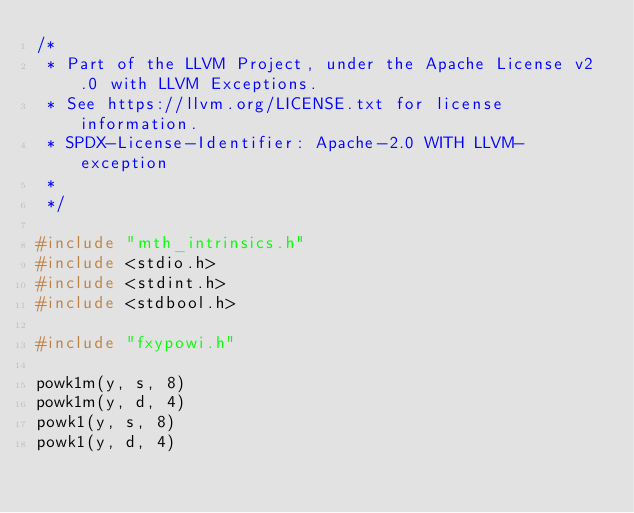<code> <loc_0><loc_0><loc_500><loc_500><_C_>/*
 * Part of the LLVM Project, under the Apache License v2.0 with LLVM Exceptions.
 * See https://llvm.org/LICENSE.txt for license information.
 * SPDX-License-Identifier: Apache-2.0 WITH LLVM-exception
 *
 */

#include "mth_intrinsics.h"
#include <stdio.h>
#include <stdint.h>
#include <stdbool.h>

#include "fxypowi.h"

powk1m(y, s, 8)
powk1m(y, d, 4)
powk1(y, s, 8)
powk1(y, d, 4)
</code> 